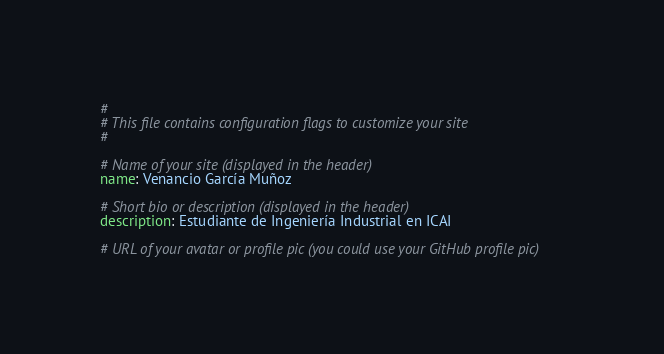Convert code to text. <code><loc_0><loc_0><loc_500><loc_500><_YAML_>#
# This file contains configuration flags to customize your site
#

# Name of your site (displayed in the header)
name: Venancio García Muñoz

# Short bio or description (displayed in the header)
description: Estudiante de Ingeniería Industrial en ICAI

# URL of your avatar or profile pic (you could use your GitHub profile pic)</code> 